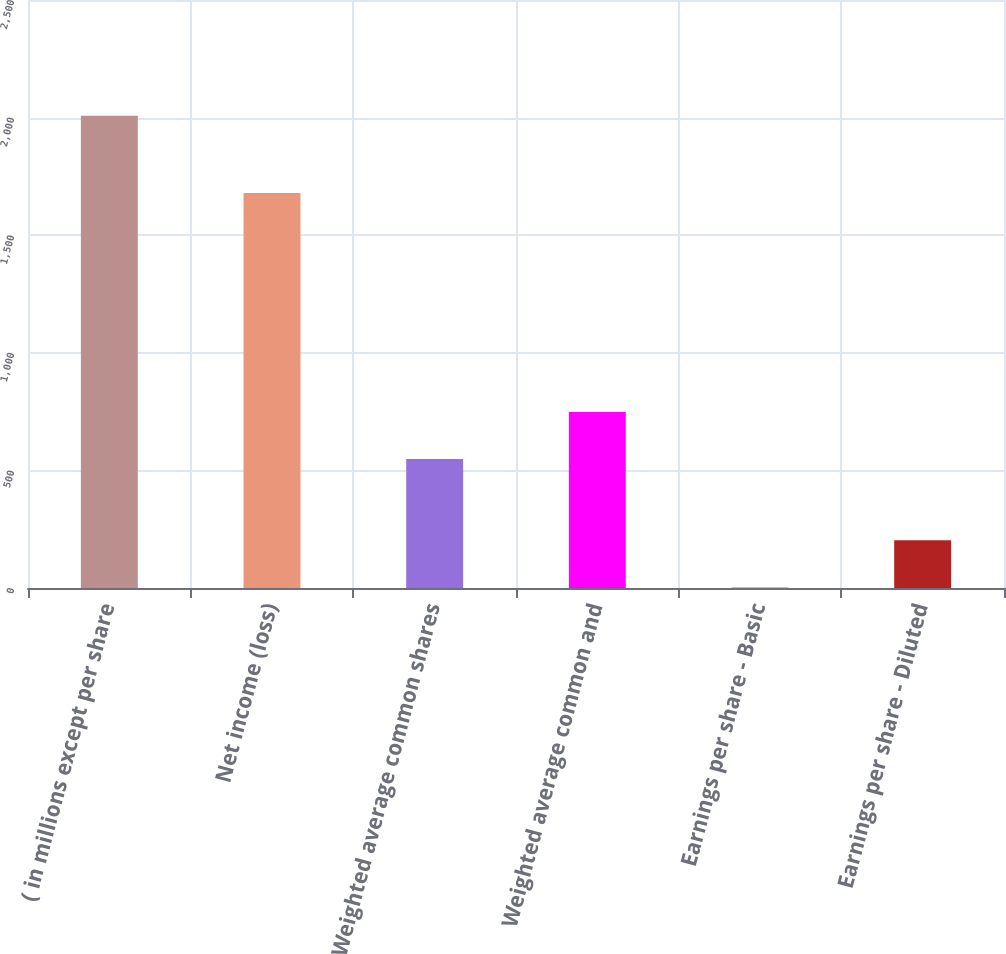Convert chart to OTSL. <chart><loc_0><loc_0><loc_500><loc_500><bar_chart><fcel>( in millions except per share<fcel>Net income (loss)<fcel>Weighted average common shares<fcel>Weighted average common and<fcel>Earnings per share - Basic<fcel>Earnings per share - Diluted<nl><fcel>2008<fcel>1679<fcel>548.3<fcel>748.79<fcel>3.06<fcel>203.55<nl></chart> 